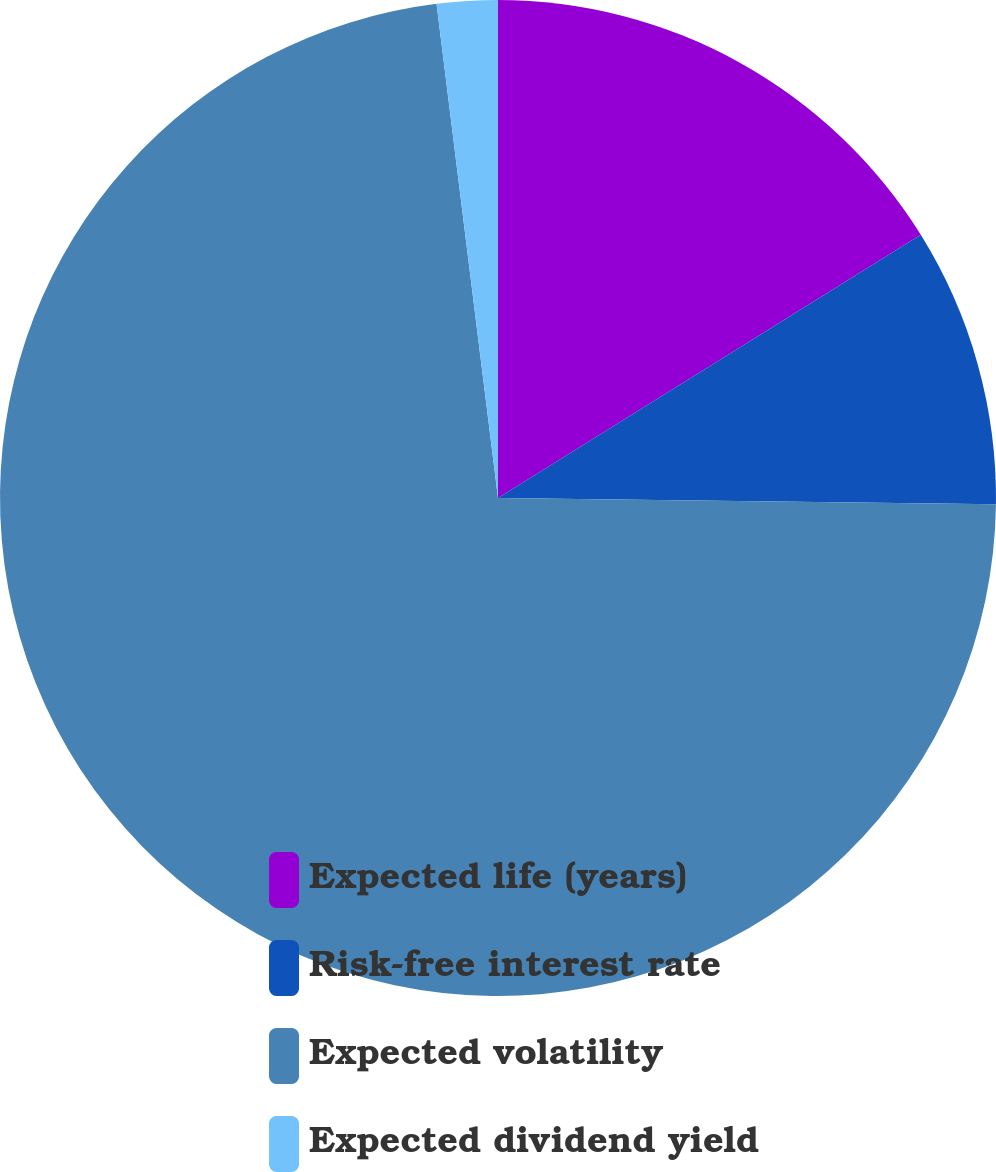Convert chart. <chart><loc_0><loc_0><loc_500><loc_500><pie_chart><fcel>Expected life (years)<fcel>Risk-free interest rate<fcel>Expected volatility<fcel>Expected dividend yield<nl><fcel>16.14%<fcel>9.06%<fcel>72.83%<fcel>1.97%<nl></chart> 